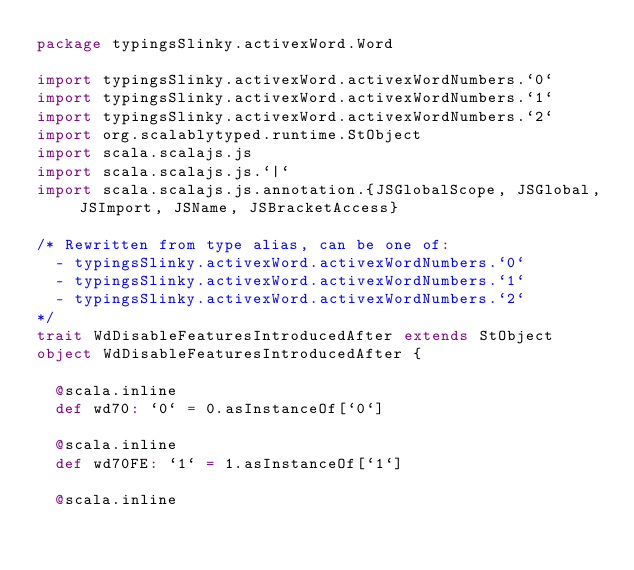Convert code to text. <code><loc_0><loc_0><loc_500><loc_500><_Scala_>package typingsSlinky.activexWord.Word

import typingsSlinky.activexWord.activexWordNumbers.`0`
import typingsSlinky.activexWord.activexWordNumbers.`1`
import typingsSlinky.activexWord.activexWordNumbers.`2`
import org.scalablytyped.runtime.StObject
import scala.scalajs.js
import scala.scalajs.js.`|`
import scala.scalajs.js.annotation.{JSGlobalScope, JSGlobal, JSImport, JSName, JSBracketAccess}

/* Rewritten from type alias, can be one of: 
  - typingsSlinky.activexWord.activexWordNumbers.`0`
  - typingsSlinky.activexWord.activexWordNumbers.`1`
  - typingsSlinky.activexWord.activexWordNumbers.`2`
*/
trait WdDisableFeaturesIntroducedAfter extends StObject
object WdDisableFeaturesIntroducedAfter {
  
  @scala.inline
  def wd70: `0` = 0.asInstanceOf[`0`]
  
  @scala.inline
  def wd70FE: `1` = 1.asInstanceOf[`1`]
  
  @scala.inline</code> 